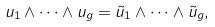<formula> <loc_0><loc_0><loc_500><loc_500>u _ { 1 } \wedge \cdots \wedge u _ { g } = \tilde { u } _ { 1 } \wedge \cdots \wedge \tilde { u } _ { g } ,</formula> 